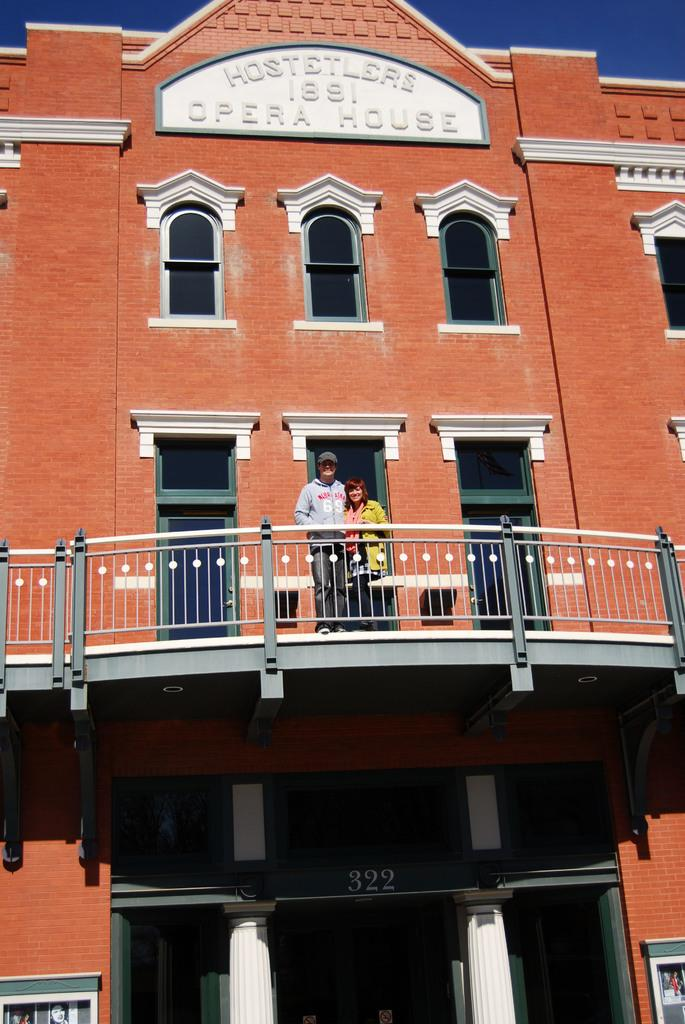What is the main structure visible in the image? There is a building in the image. Can you describe the people in the image? A: There is a couple standing in the balcony of the building. What can be seen in the background of the image? The sky is visible in the background of the image. What type of vase is being used by the couple in the image? There is no vase present in the image; the couple is standing in the balcony of the building. 